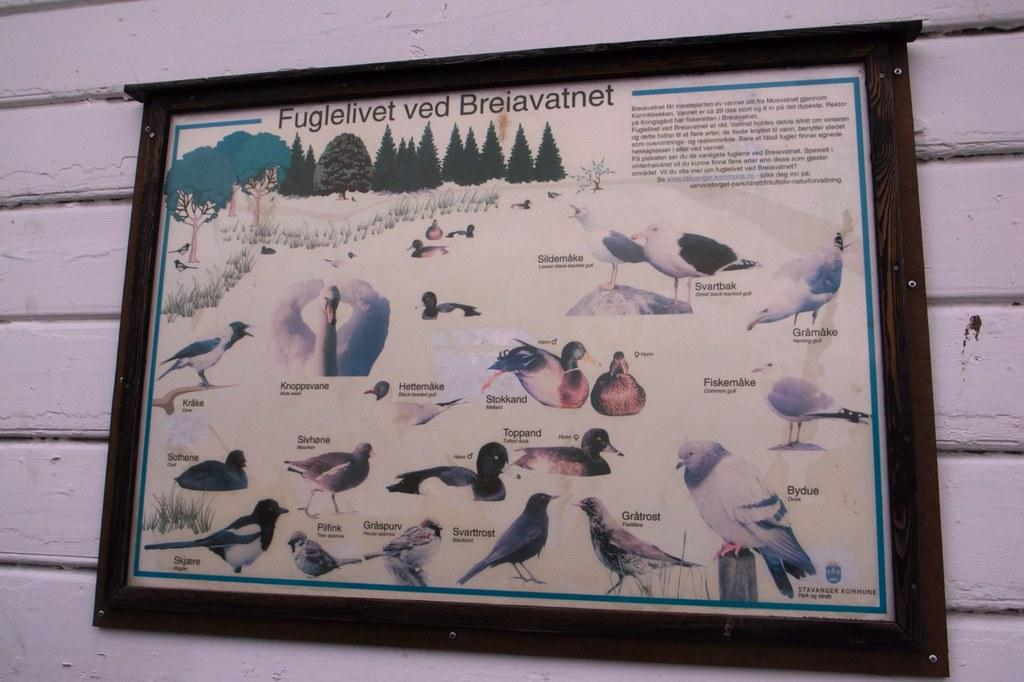What is the main object in the image? There is a frame in the image. Where is the frame located? The frame is placed on a wall. Can you see a bee buzzing around the frame in the image? There is no bee present in the image; it only features a frame placed on a wall. 